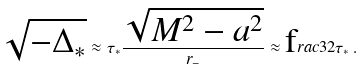Convert formula to latex. <formula><loc_0><loc_0><loc_500><loc_500>\sqrt { - \Delta _ { * } } \approx \tau _ { * } \frac { \sqrt { M ^ { 2 } - a ^ { 2 } } } { r _ { - } } \approx \text  frac{3} { 2 } \tau _ { * } \, .</formula> 